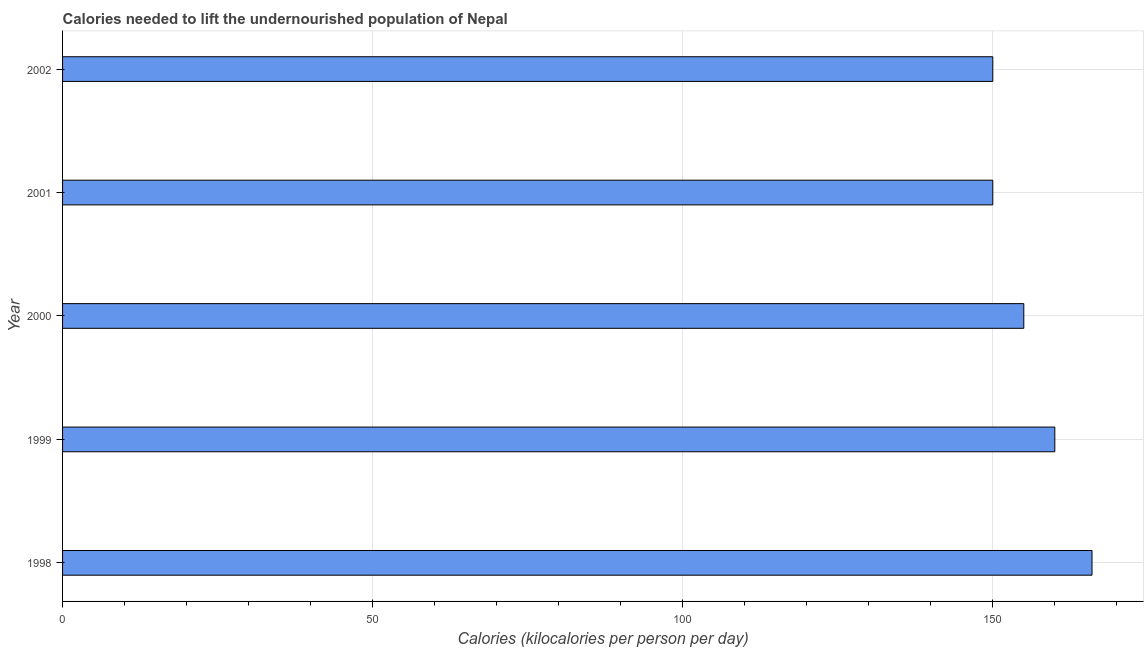Does the graph contain grids?
Provide a short and direct response. Yes. What is the title of the graph?
Your answer should be very brief. Calories needed to lift the undernourished population of Nepal. What is the label or title of the X-axis?
Your response must be concise. Calories (kilocalories per person per day). What is the label or title of the Y-axis?
Ensure brevity in your answer.  Year. What is the depth of food deficit in 1998?
Keep it short and to the point. 166. Across all years, what is the maximum depth of food deficit?
Make the answer very short. 166. Across all years, what is the minimum depth of food deficit?
Provide a succinct answer. 150. In which year was the depth of food deficit minimum?
Offer a terse response. 2001. What is the sum of the depth of food deficit?
Offer a very short reply. 781. What is the average depth of food deficit per year?
Offer a terse response. 156. What is the median depth of food deficit?
Your response must be concise. 155. What is the ratio of the depth of food deficit in 2000 to that in 2002?
Give a very brief answer. 1.03. Is the difference between the depth of food deficit in 2001 and 2002 greater than the difference between any two years?
Your answer should be compact. No. Is the sum of the depth of food deficit in 2000 and 2001 greater than the maximum depth of food deficit across all years?
Provide a succinct answer. Yes. How many bars are there?
Make the answer very short. 5. How many years are there in the graph?
Offer a very short reply. 5. What is the difference between two consecutive major ticks on the X-axis?
Give a very brief answer. 50. What is the Calories (kilocalories per person per day) of 1998?
Keep it short and to the point. 166. What is the Calories (kilocalories per person per day) of 1999?
Your answer should be compact. 160. What is the Calories (kilocalories per person per day) in 2000?
Your response must be concise. 155. What is the Calories (kilocalories per person per day) of 2001?
Provide a short and direct response. 150. What is the Calories (kilocalories per person per day) in 2002?
Keep it short and to the point. 150. What is the difference between the Calories (kilocalories per person per day) in 1998 and 2000?
Keep it short and to the point. 11. What is the difference between the Calories (kilocalories per person per day) in 1999 and 2000?
Ensure brevity in your answer.  5. What is the difference between the Calories (kilocalories per person per day) in 1999 and 2001?
Make the answer very short. 10. What is the difference between the Calories (kilocalories per person per day) in 2000 and 2001?
Give a very brief answer. 5. What is the difference between the Calories (kilocalories per person per day) in 2000 and 2002?
Make the answer very short. 5. What is the difference between the Calories (kilocalories per person per day) in 2001 and 2002?
Make the answer very short. 0. What is the ratio of the Calories (kilocalories per person per day) in 1998 to that in 1999?
Keep it short and to the point. 1.04. What is the ratio of the Calories (kilocalories per person per day) in 1998 to that in 2000?
Provide a short and direct response. 1.07. What is the ratio of the Calories (kilocalories per person per day) in 1998 to that in 2001?
Your answer should be very brief. 1.11. What is the ratio of the Calories (kilocalories per person per day) in 1998 to that in 2002?
Your answer should be very brief. 1.11. What is the ratio of the Calories (kilocalories per person per day) in 1999 to that in 2000?
Give a very brief answer. 1.03. What is the ratio of the Calories (kilocalories per person per day) in 1999 to that in 2001?
Your answer should be compact. 1.07. What is the ratio of the Calories (kilocalories per person per day) in 1999 to that in 2002?
Offer a terse response. 1.07. What is the ratio of the Calories (kilocalories per person per day) in 2000 to that in 2001?
Ensure brevity in your answer.  1.03. What is the ratio of the Calories (kilocalories per person per day) in 2000 to that in 2002?
Offer a very short reply. 1.03. 